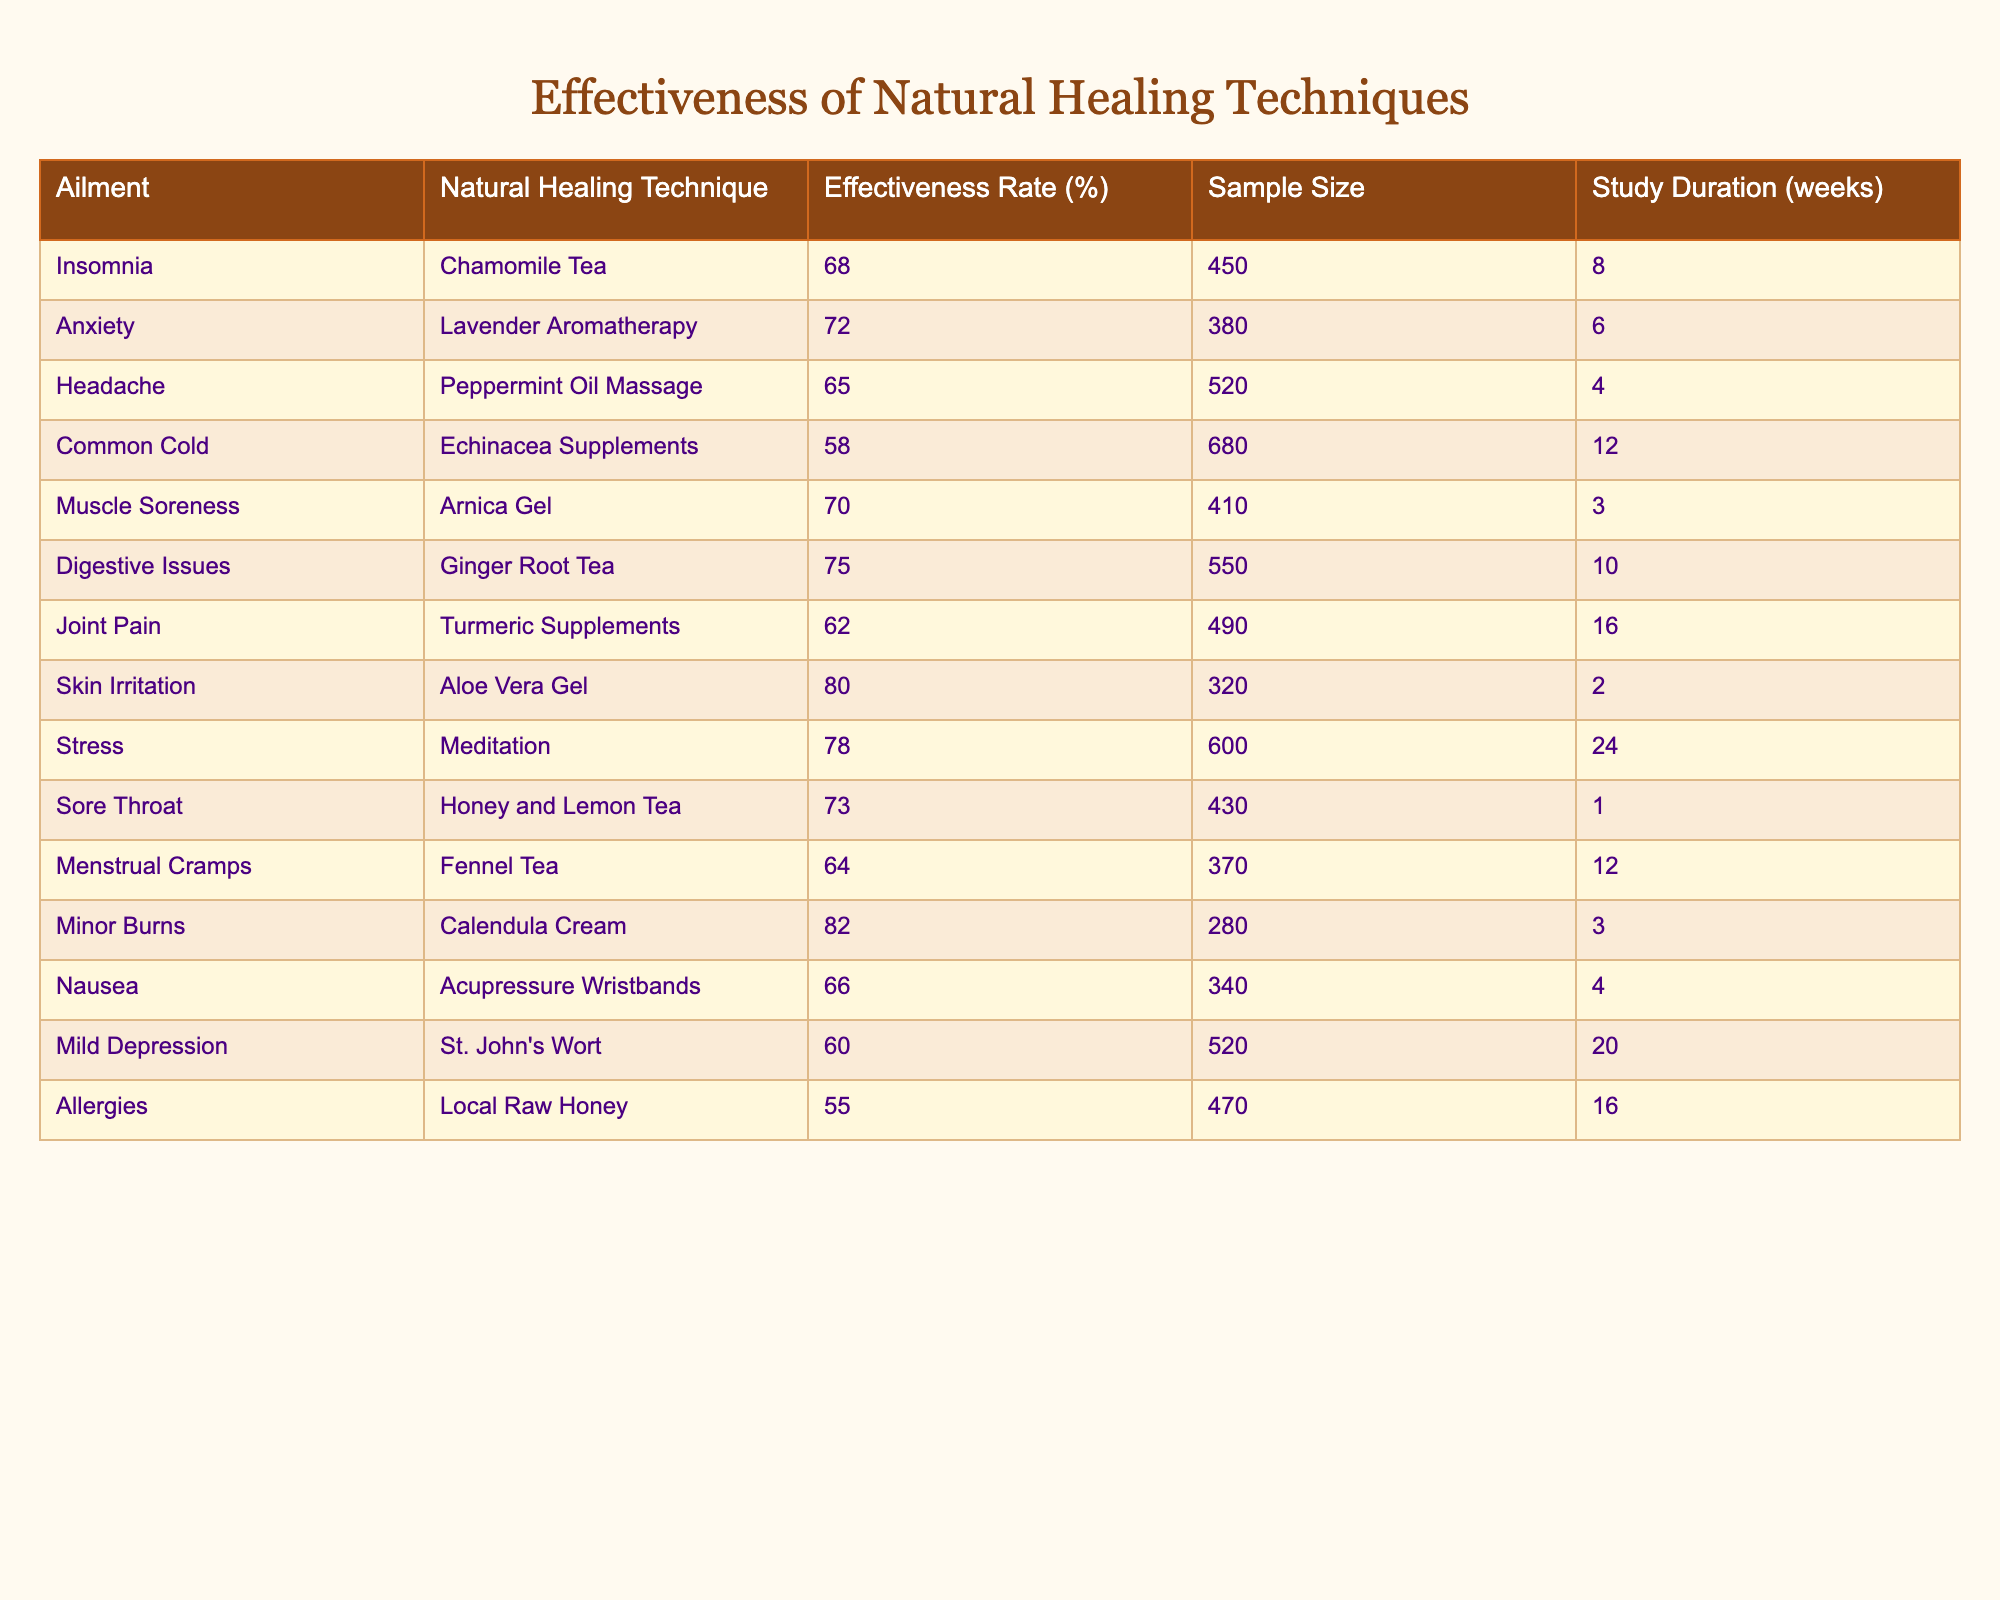What is the effectiveness rate of Chamomile Tea for insomnia? According to the table, the effectiveness rate for Chamomile Tea in treating insomnia is listed directly under the "Effectiveness Rate (%)" column. The corresponding value is 68%.
Answer: 68% Which natural healing technique has the highest effectiveness rate? By comparing all effectiveness rates listed in the table, Aloe Vera Gel with an effectiveness rate of 80% is the highest among all techniques.
Answer: Aloe Vera Gel How many weeks was the study conducted for the Anxiety treatment? The table indicates the duration of the study in weeks under the "Study Duration (weeks)" column for Anxiety, which is 6 weeks.
Answer: 6 What is the effectiveness rate of Echinacea Supplements for the common cold? The table shows that the effectiveness rate of Echinacea Supplements for treating the common cold is 58%.
Answer: 58% Which natural healing technique is used for muscle soreness, and what is its effectiveness rate? Referring to the table, the technique used for muscle soreness is Arnica Gel, which has an effectiveness rate of 70%.
Answer: Arnica Gel, 70% Is the effectiveness rate of Local Raw Honey for allergies higher than average effectiveness rates of the other remedies? To determine this, calculate the average effectiveness rate of all techniques by adding the effectiveness rates (from the table) and dividing by the total number of techniques (14). The average is approximately 66.43%. The effectiveness rate for Local Raw Honey is 55%, which is lower than the average.
Answer: No What percentage difference is there between the effectiveness rates of Aloe Vera Gel and St. John's Wort? First, find the effectiveness rates from the table: Aloe Vera Gel is 80% and St. John's Wort is 60%. Then, subtract the smaller from the larger (80 - 60 = 20). To find the percentage difference, divide this by the effectiveness of St. John's Wort (20 / 60 ≈ 0.333) and multiply by 100, resulting in approximately 33.33%.
Answer: Approximately 33.33% Which technique has the longest study duration, and what ailment does it address? In the table, look for the longest study duration under "Study Duration (weeks)", which corresponds to Meditation with a duration of 24 weeks, addressing stress.
Answer: Meditation, 24 weeks What is the average effectiveness rate of the natural remedies for menstrual cramps, muscle soreness, and headaches? The effectiveness rates for these three ailments are: Menstrual Cramps (64%), Muscle Soreness (70%), and Headache (65%). To find the average, sum these rates (64 + 70 + 65 = 199) and divide by 3, resulting in an average of approximately 66.33%.
Answer: Approximately 66.33% Are there any natural healing techniques with an effectiveness rate below 60%? By checking the effectiveness rates in the table, Local Raw Honey (55%) and Echinacea Supplements (58%) have rates below 60%. Hence, the answer is yes.
Answer: Yes What is the relationship between study duration and effectiveness rates in the table? Examining the values for study duration and effectiveness rates reveals that longer studies do not necessarily equate to higher effectiveness. For instance, Meditation with a long duration of 24 weeks has a high effectiveness rate, while some shorter studies have lower effectiveness rates. However, a definitive pattern cannot be established solely from this table.
Answer: No clear relationship 